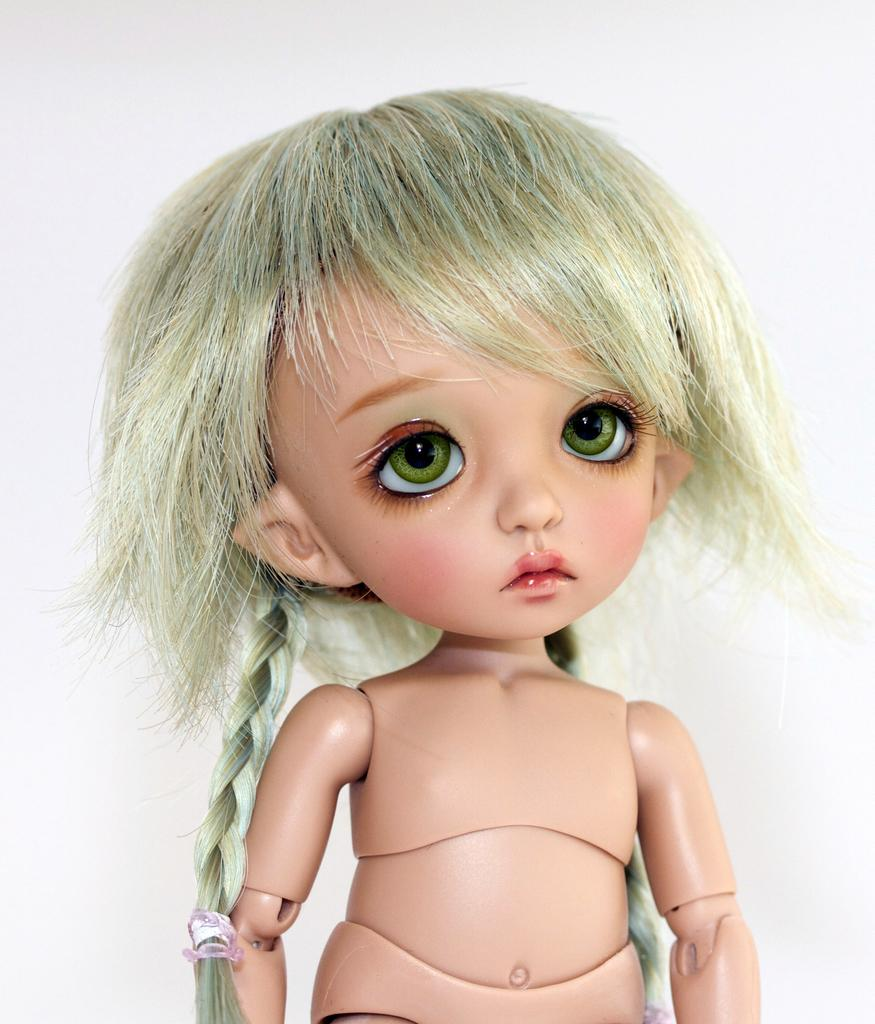What is the main subject of the image? There is a doll in the image. What color is the background of the image? The background of the image is white. What type of tree is visible in the background of the image? There is no tree visible in the background of the image; the background is white. Is the doll holding a notebook in the image? There is no mention of a notebook in the image, so it cannot be determined if the doll is holding one. 